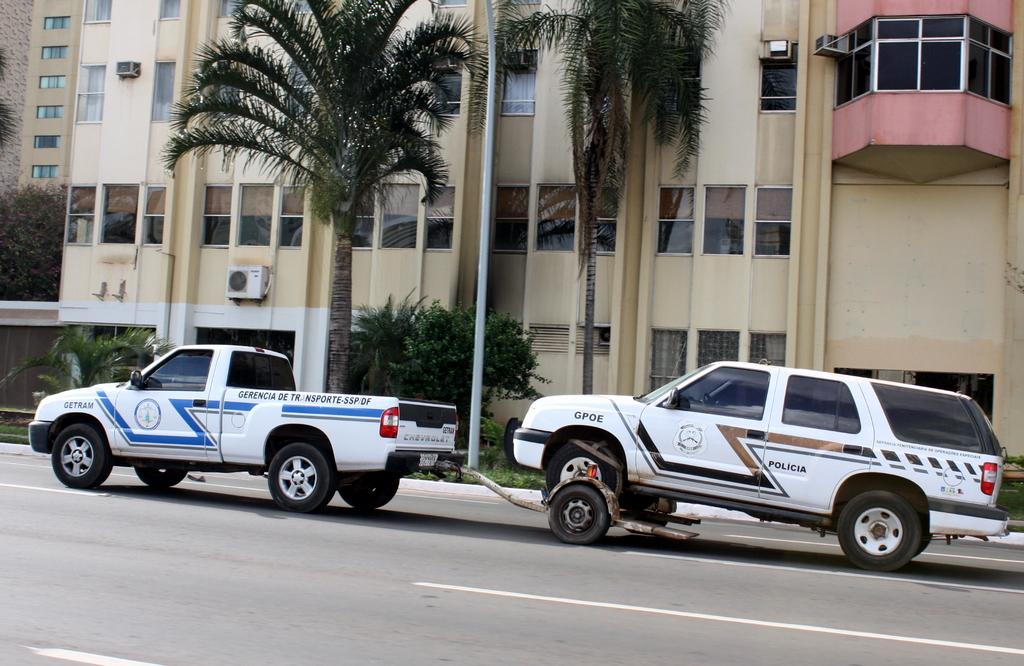What type of vehicle is the main subject of the image? There is a truck in the image. Is there any other vehicle associated with the truck? Yes, there is a vehicle attached to the truck in the image. What can be seen in the background behind the vehicles? Trees are visible behind the vehicles. What is located behind the trees in the image? There is a huge building behind the trees. What type of toothbrush is being used to clean the truck in the image? There is no toothbrush present in the image, and the truck is not being cleaned. 